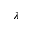<formula> <loc_0><loc_0><loc_500><loc_500>\lambda</formula> 